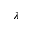<formula> <loc_0><loc_0><loc_500><loc_500>\lambda</formula> 